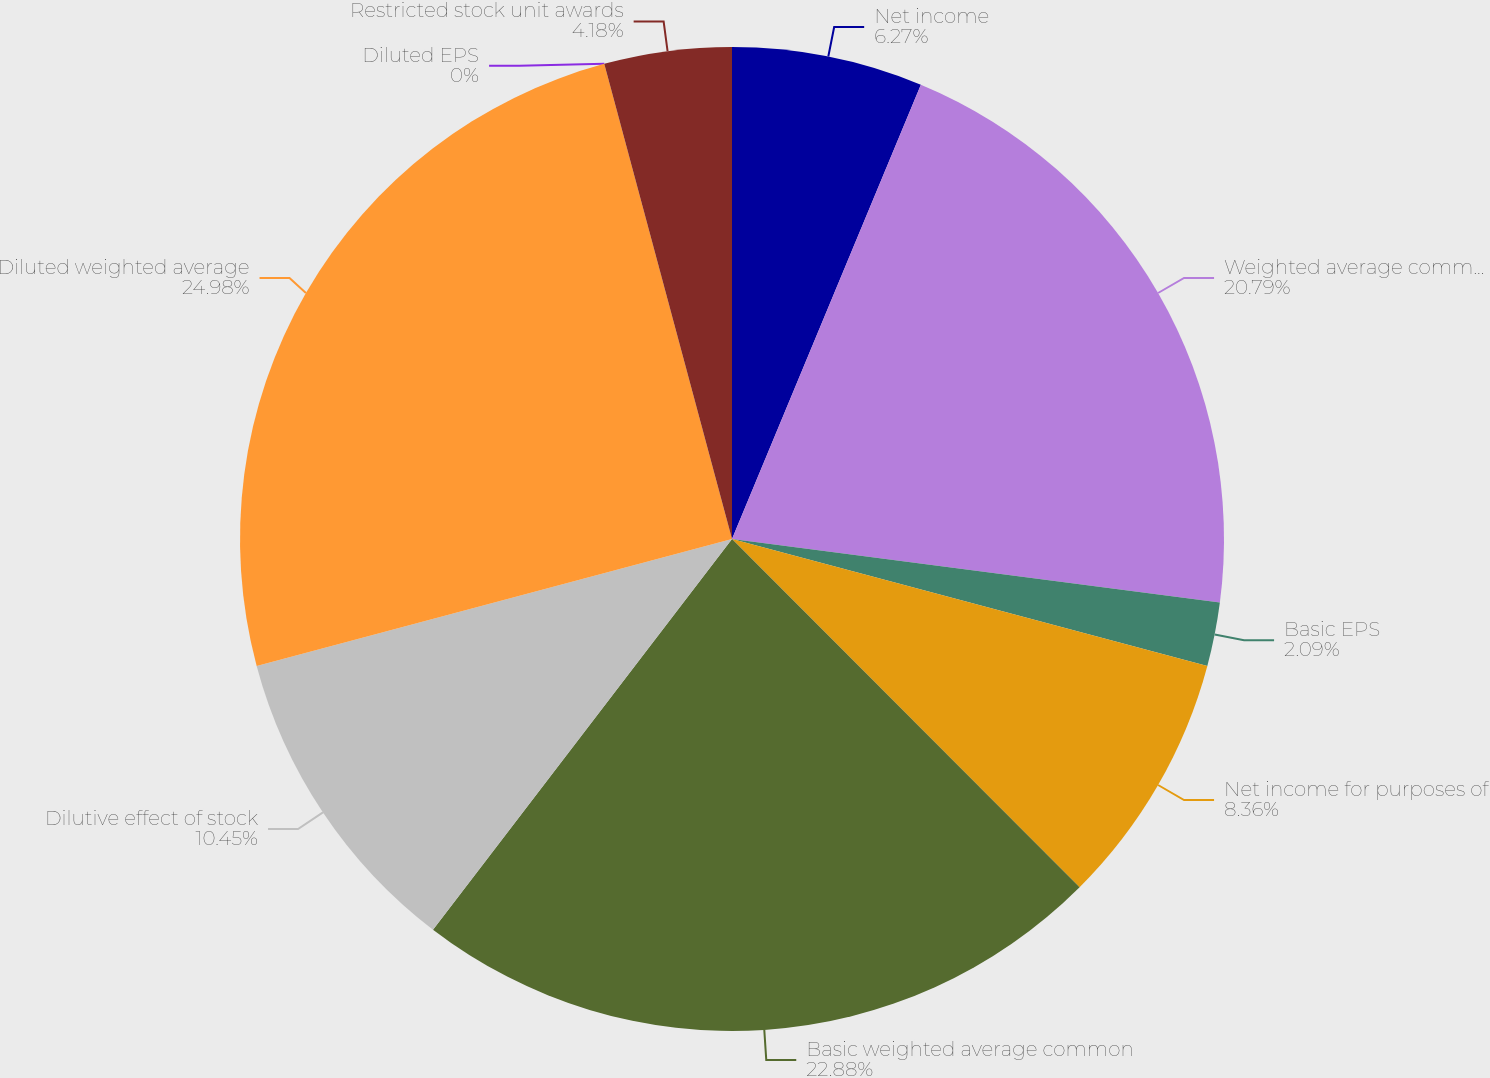Convert chart to OTSL. <chart><loc_0><loc_0><loc_500><loc_500><pie_chart><fcel>Net income<fcel>Weighted average common shares<fcel>Basic EPS<fcel>Net income for purposes of<fcel>Basic weighted average common<fcel>Dilutive effect of stock<fcel>Diluted weighted average<fcel>Diluted EPS<fcel>Restricted stock unit awards<nl><fcel>6.27%<fcel>20.79%<fcel>2.09%<fcel>8.36%<fcel>22.88%<fcel>10.45%<fcel>24.97%<fcel>0.0%<fcel>4.18%<nl></chart> 